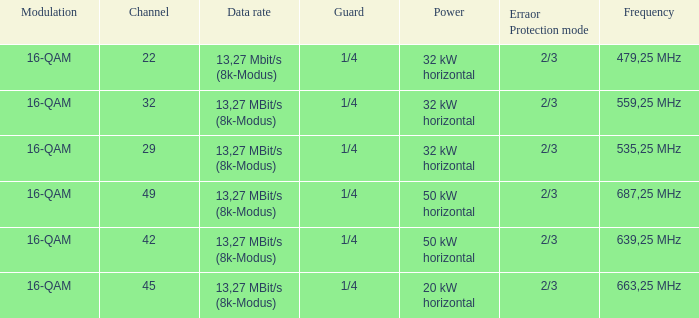On channel 32, when the power is 32 kW horizontal, what is the modulation? 16-QAM. Would you mind parsing the complete table? {'header': ['Modulation', 'Channel', 'Data rate', 'Guard', 'Power', 'Erraor Protection mode', 'Frequency'], 'rows': [['16-QAM', '22', '13,27 Mbit/s (8k-Modus)', '1/4', '32 kW horizontal', '2/3', '479,25 MHz'], ['16-QAM', '32', '13,27 MBit/s (8k-Modus)', '1/4', '32 kW horizontal', '2/3', '559,25 MHz'], ['16-QAM', '29', '13,27 MBit/s (8k-Modus)', '1/4', '32 kW horizontal', '2/3', '535,25 MHz'], ['16-QAM', '49', '13,27 MBit/s (8k-Modus)', '1/4', '50 kW horizontal', '2/3', '687,25 MHz'], ['16-QAM', '42', '13,27 MBit/s (8k-Modus)', '1/4', '50 kW horizontal', '2/3', '639,25 MHz'], ['16-QAM', '45', '13,27 MBit/s (8k-Modus)', '1/4', '20 kW horizontal', '2/3', '663,25 MHz']]} 